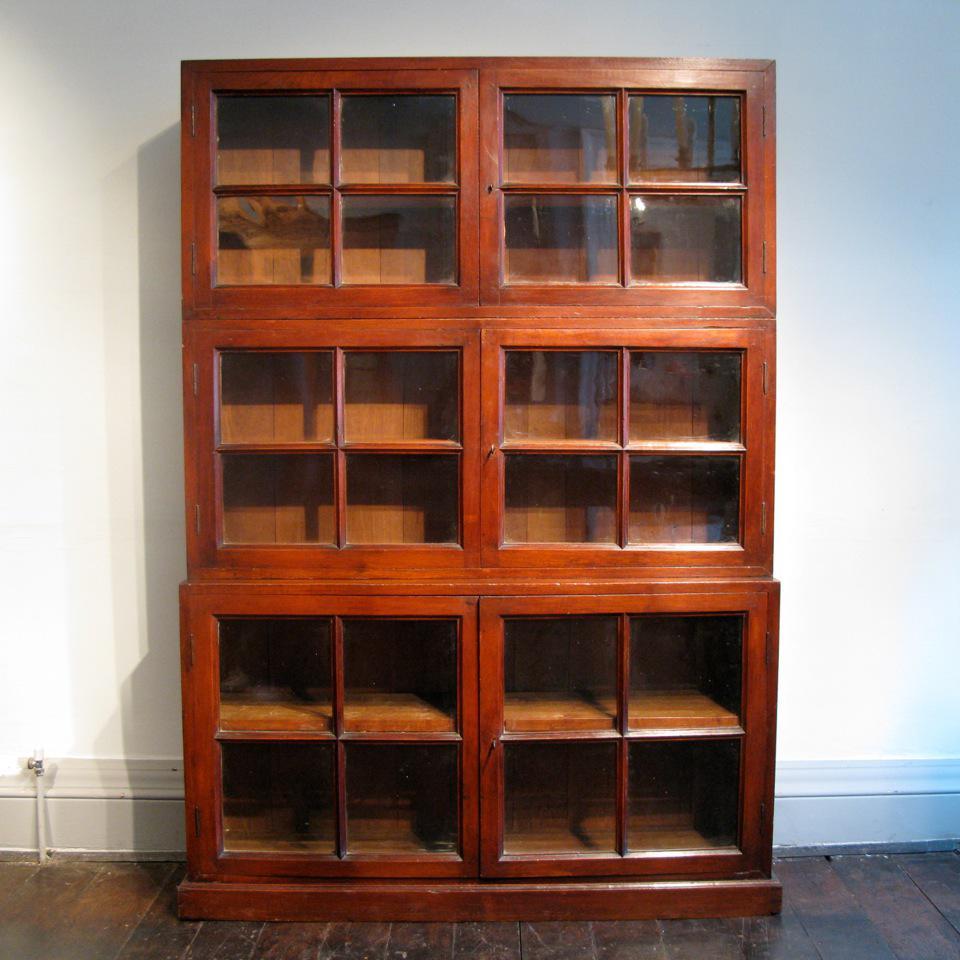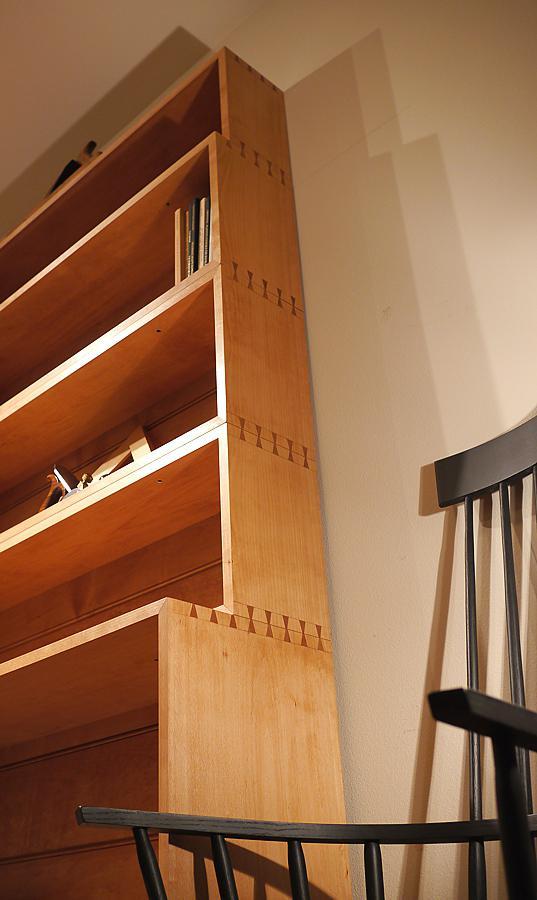The first image is the image on the left, the second image is the image on the right. Examine the images to the left and right. Is the description "One of the images includes a bookcase with glass on the front." accurate? Answer yes or no. Yes. The first image is the image on the left, the second image is the image on the right. Considering the images on both sides, is "The cabinet in the left image has glass panes." valid? Answer yes or no. Yes. 